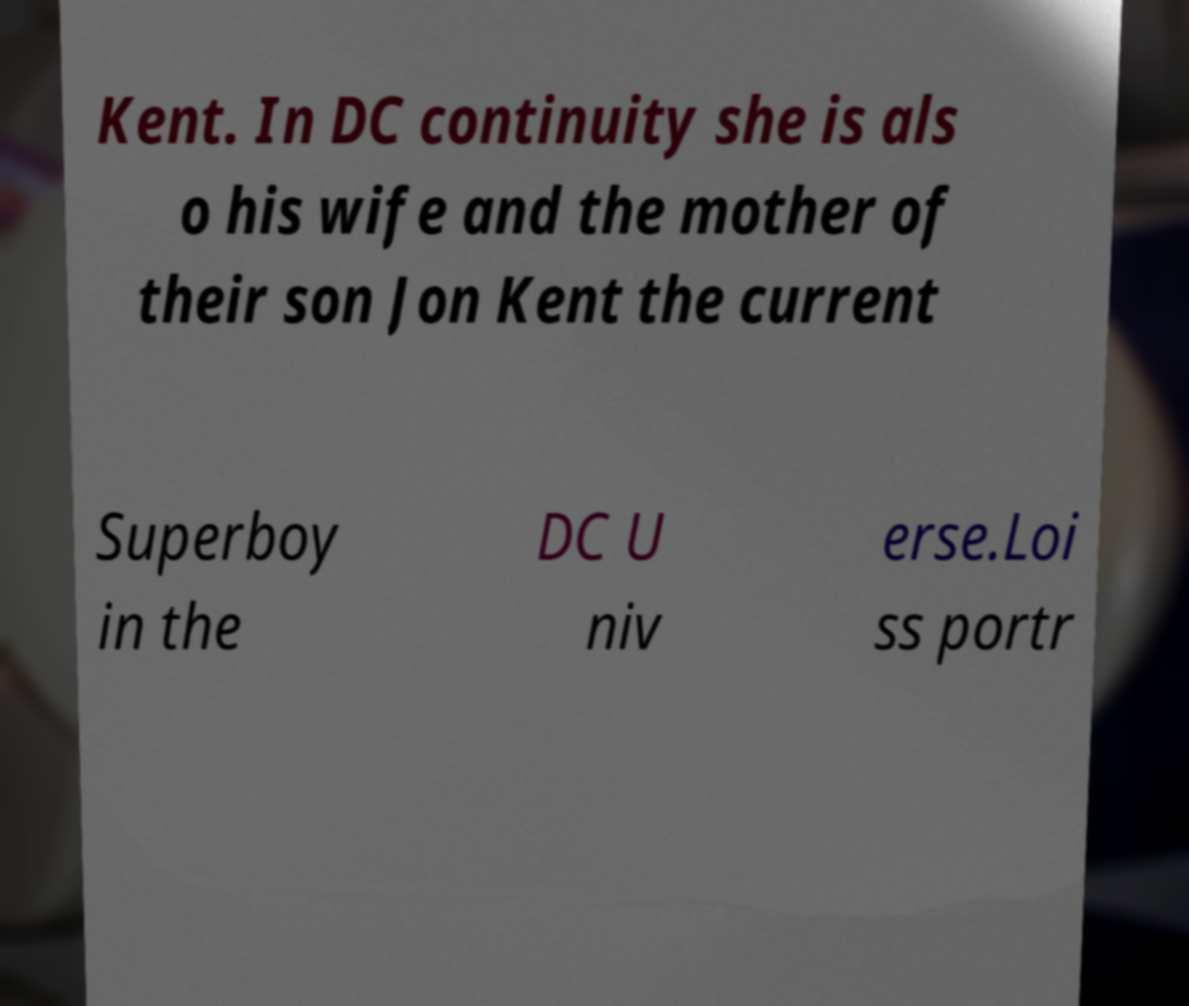Can you read and provide the text displayed in the image?This photo seems to have some interesting text. Can you extract and type it out for me? Kent. In DC continuity she is als o his wife and the mother of their son Jon Kent the current Superboy in the DC U niv erse.Loi ss portr 